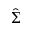Convert formula to latex. <formula><loc_0><loc_0><loc_500><loc_500>\hat { \Sigma }</formula> 